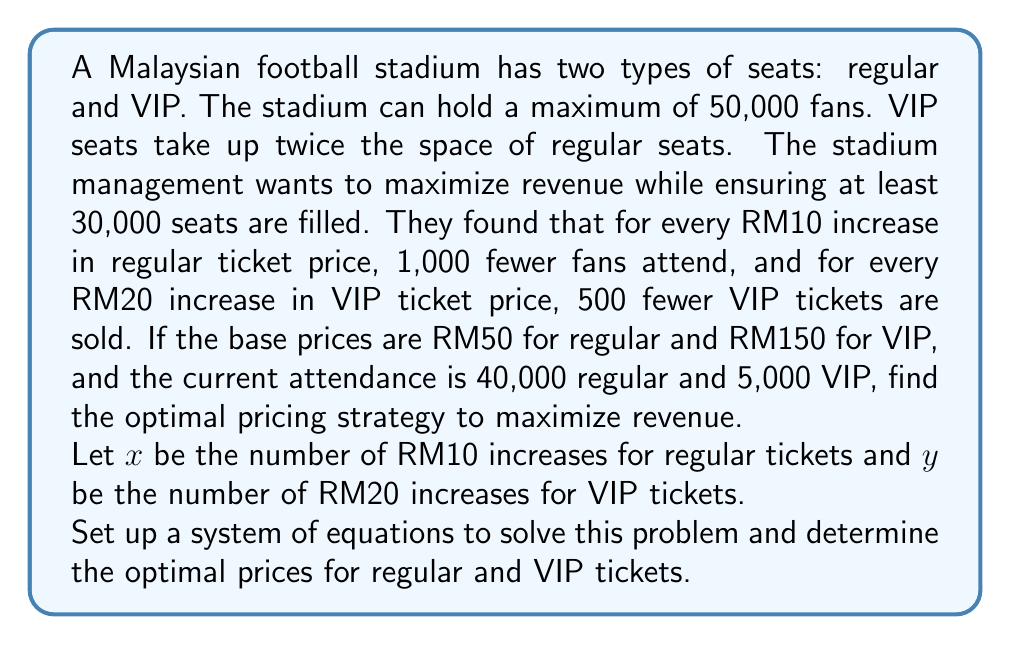Teach me how to tackle this problem. Let's approach this step-by-step:

1) First, let's set up equations for the number of attendees:
   Regular attendees: $40,000 - 1,000x$
   VIP attendees: $5,000 - 500y$

2) The total number of seats constraint:
   $$(40,000 - 1,000x) + 2(5,000 - 500y) \leq 50,000$$

3) The minimum attendance constraint:
   $$(40,000 - 1,000x) + (5,000 - 500y) \geq 30,000$$

4) The revenue function to maximize:
   $$R = (50 + 10x)(40,000 - 1,000x) + (150 + 20y)(5,000 - 500y)$$

5) Expand the revenue function:
   $$R = 2,000,000 + 400,000x - 10,000x^2 + 750,000 + 100,000y - 10,000y^2$$
   $$R = 2,750,000 + 400,000x - 10,000x^2 + 100,000y - 10,000y^2$$

6) To find the maximum, we take partial derivatives and set them to zero:
   $$\frac{\partial R}{\partial x} = 400,000 - 20,000x = 0$$
   $$\frac{\partial R}{\partial y} = 100,000 - 20,000y = 0$$

7) Solving these equations:
   $$x = 20$$ and $$y = 5$$

8) Check if these values satisfy the constraints:
   Total seats: $20,000 + 2(2,500) = 25,000 \leq 50,000$ (satisfied)
   Minimum attendance: $20,000 + 2,500 = 22,500 \geq 30,000$ (not satisfied)

9) Since the minimum attendance constraint is not met, we need to solve the system of equations:
   $$40,000 - 1,000x + 5,000 - 500y = 30,000$$
   $$40,000 - 1,000x + 2(5,000 - 500y) = 50,000$$

10) Solving this system:
    $$x = 10$$ and $$y = 10$$

11) The optimal prices are:
    Regular: RM50 + (10 * RM10) = RM150
    VIP: RM150 + (10 * RM20) = RM350

12) The maximum revenue is:
    $$R = (150)(30,000) + (350)(0) = 4,500,000$$
Answer: Regular tickets: RM150, VIP tickets: RM350 